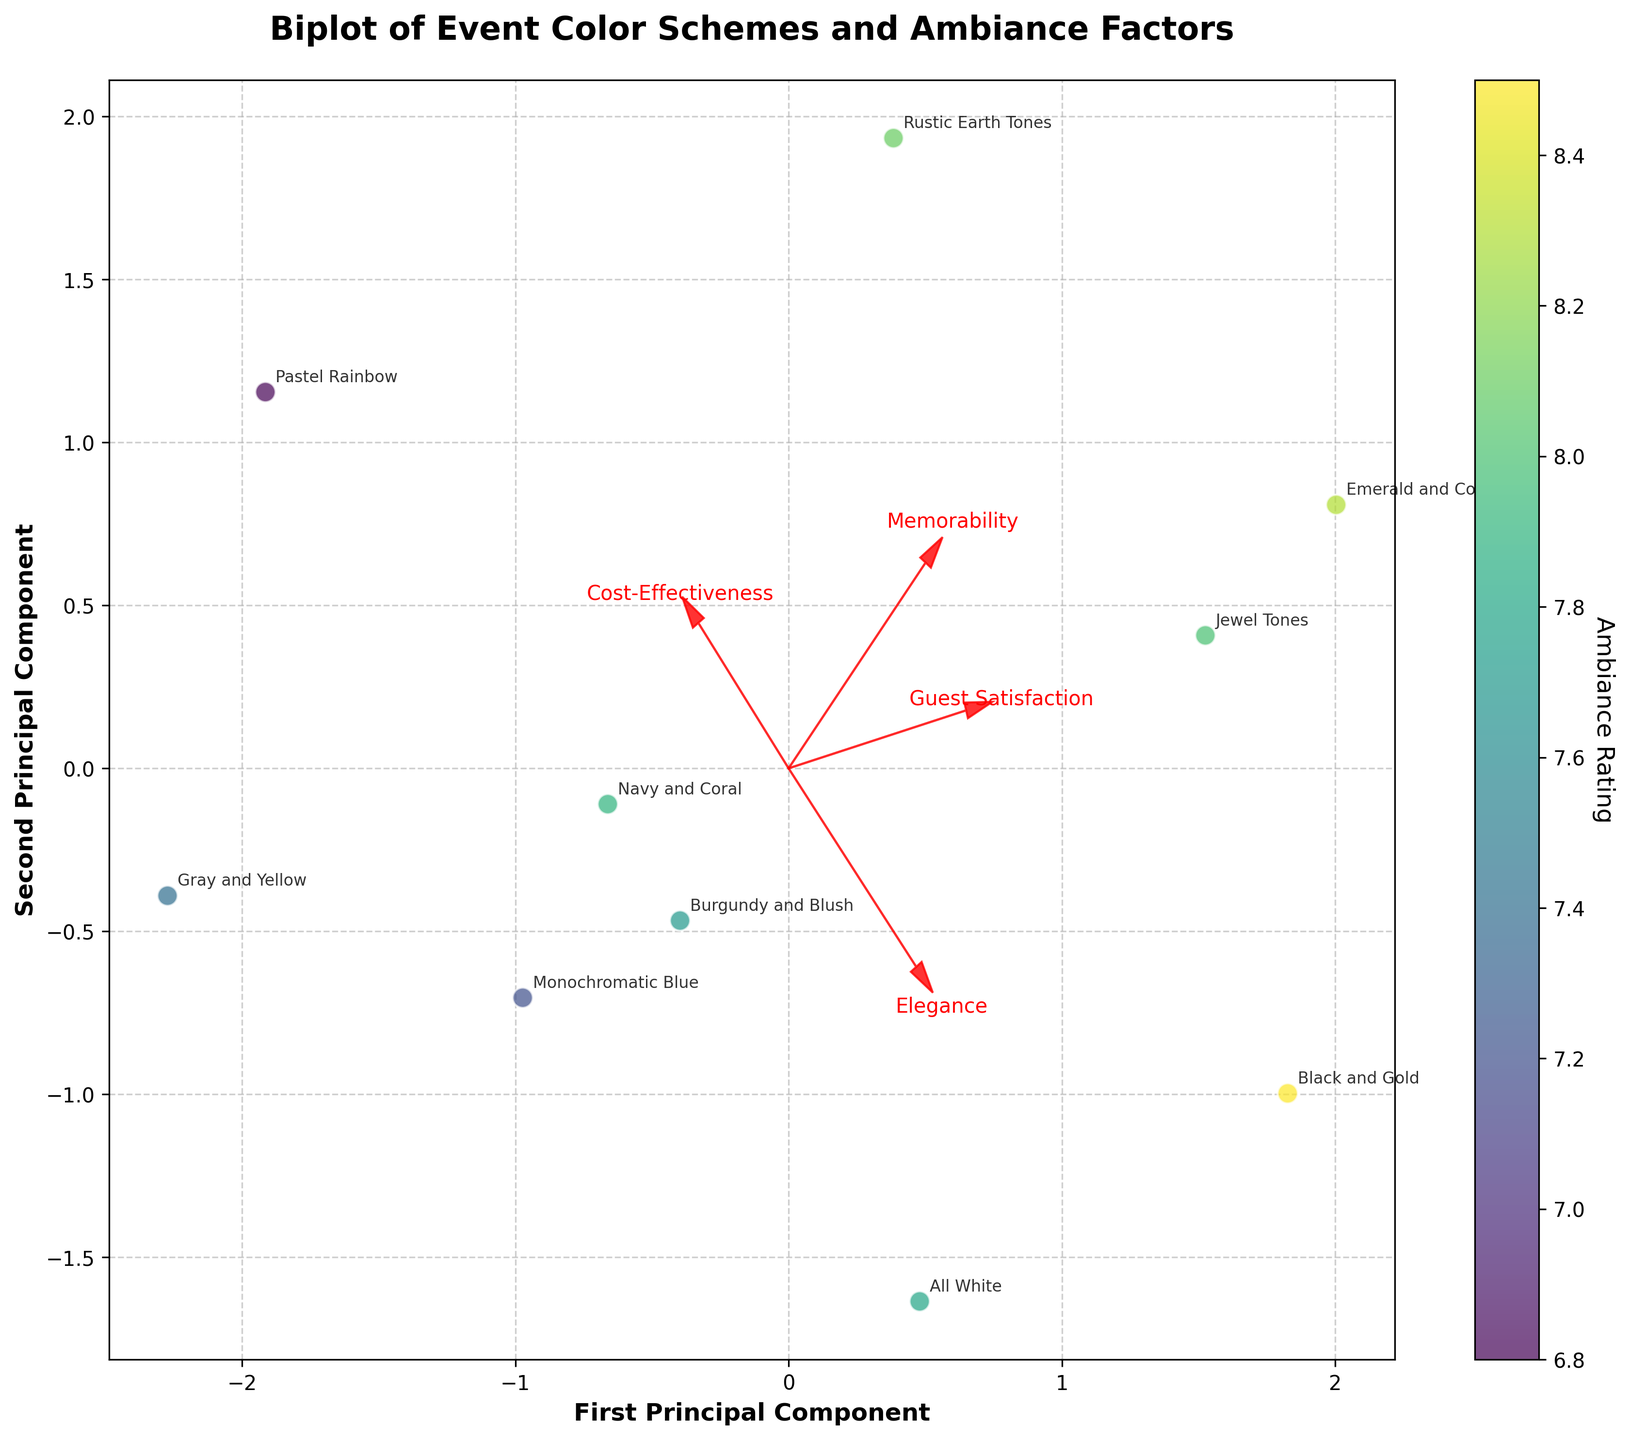How is elegance represented in the biplot? Elegance is represented by the direction and length of its vector. We see the red arrow labeled "Elegance" pointing in a certain direction, indicating the contribution of elegance to the first and second principal components.
Answer: By a red arrow labeled "Elegance" What does the first principal component represent? The first principal component is the horizontal axis of the biplot. It captures the maximum variance in the data among "Elegance," "Memorability," "Cost-Effectiveness," and "Guest Satisfaction," showing how much each factor contributes to differences between the data points.
Answer: Maximum variance in the data Which color scheme has the highest ambiance rating? We look for the color scheme positioned at the point with the highest value on the color bar (which indicates ambiance rating). By finding the lightest point, we see that "Black and Gold" has the highest ambiance rating.
Answer: Black and Gold What does the arrow direction indicate in a biplot? The direction of the arrows in a biplot indicates the influence of each variable. A variable pointing to the right has a strong positive correlation with the first principal component, while a variable pointing upwards has a strong positive correlation with the second principal component.
Answer: Influence of each variable How do "Rustic Earth Tones" and "All White" compare in terms of their principal component scores? We refer to the positions of "Rustic Earth Tones" and "All White" on the plot. "Rustic Earth Tones" is positioned higher on the second principal component, indicating a higher score, whereas "All White" is more varied in the first principal component.
Answer: "Rustic Earth Tones" higher on the second principal component; "All White" more varied on the first principal component Which factor seems to be negatively correlated with the first principal component? We identify arrows pointing in the opposite direction of the first principal component (horizontal axis). "Memorability" has an arrow pointing slightly to the left, indicating a negative correlation.
Answer: Memorability Which color scheme is closest to the point where the "Elegance" vector ends? We follow the "Elegance" vector and look for the nearest data point. The "Black and Gold" color scheme is closest to the endpoint of the "Elegance" vector.
Answer: Black and Gold How does "Guest Satisfaction" relate to the second principal component? By examining the plot, the arrow for "Guest Satisfaction" points upward, meaning it positively correlates with the second principal component.
Answer: Positive correlation What is the general trend for the influence of "Cost-Effectiveness"? The "Cost-Effectiveness" vector is pointing rightward and slightly downward, indicating it correlates positively with the first principal component and less so with the second.
Answer: Positive on the first principal component Are there any color schemes that appear to be moderate in all factors? By analyzing the spread and clustering of points, "Gray and Yellow" appears moderate in all factors as it is centrally located and is not extreme in any direction.
Answer: Gray and Yellow 